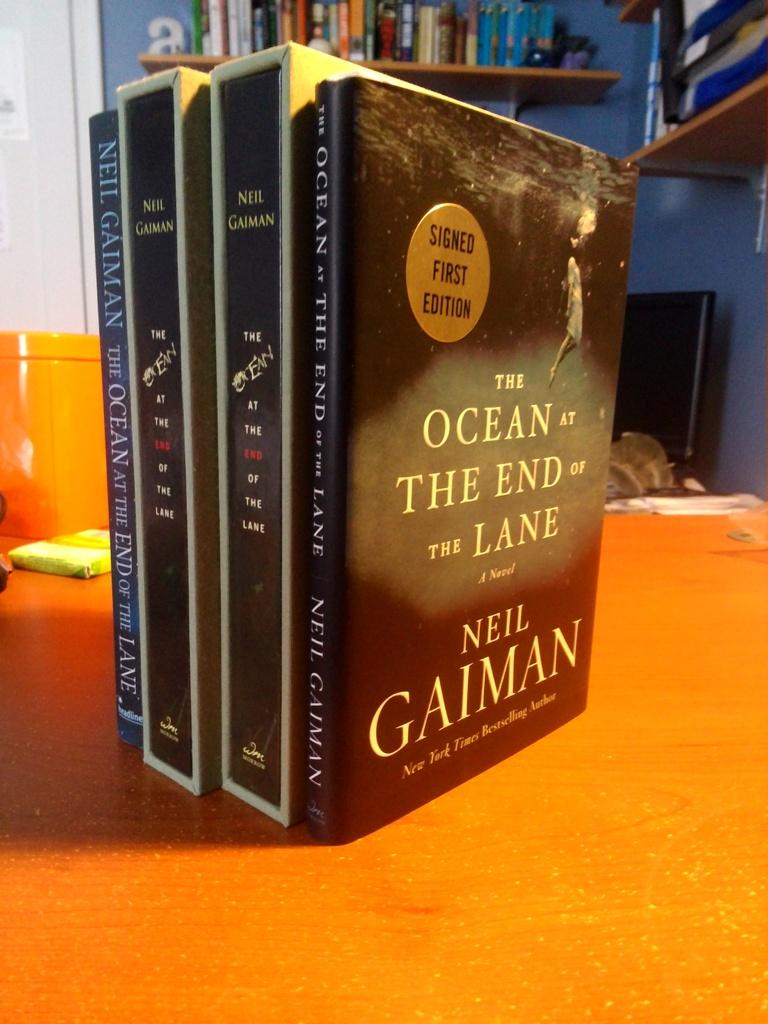What is the title of this book?
Offer a very short reply. The ocean at the end of the lane. 